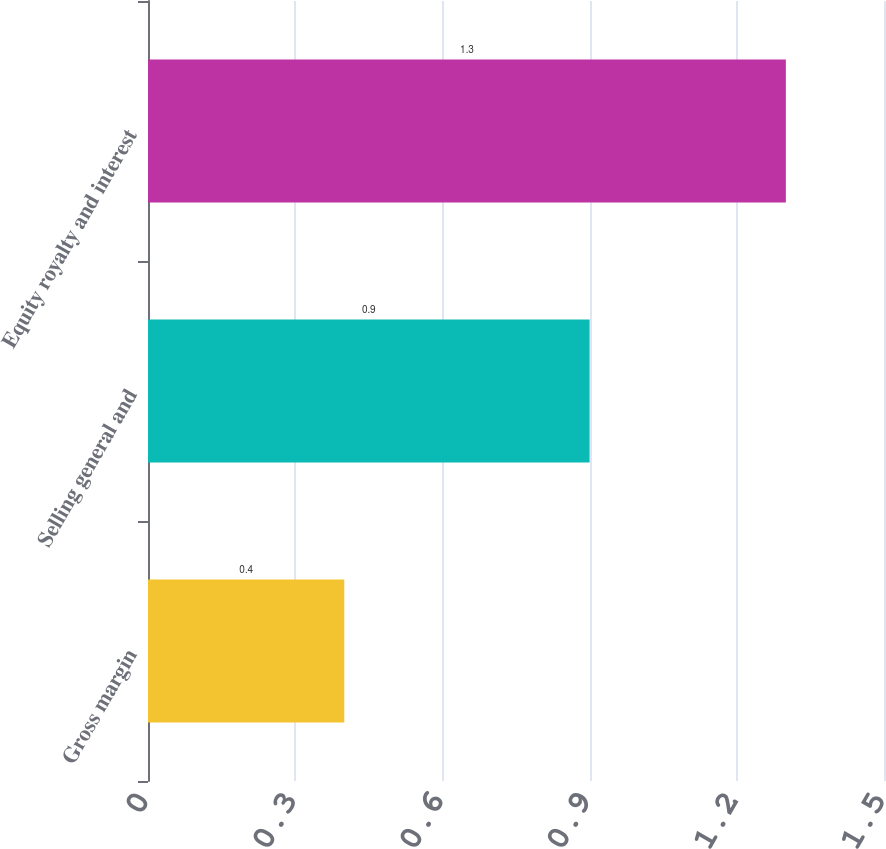Convert chart to OTSL. <chart><loc_0><loc_0><loc_500><loc_500><bar_chart><fcel>Gross margin<fcel>Selling general and<fcel>Equity royalty and interest<nl><fcel>0.4<fcel>0.9<fcel>1.3<nl></chart> 